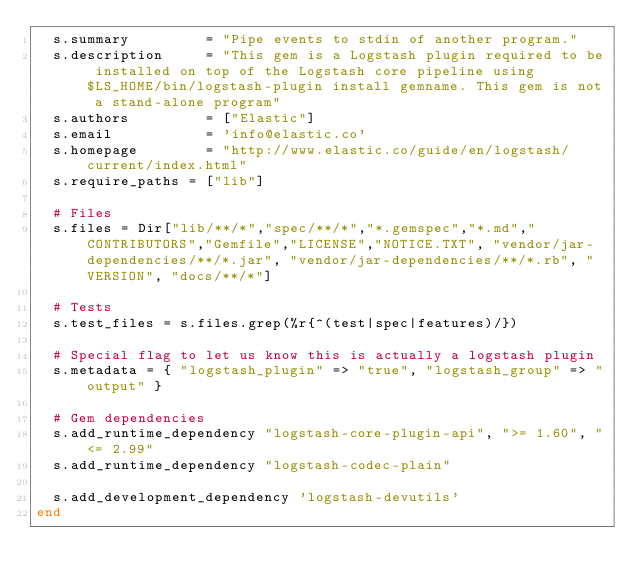<code> <loc_0><loc_0><loc_500><loc_500><_Ruby_>  s.summary         = "Pipe events to stdin of another program."
  s.description     = "This gem is a Logstash plugin required to be installed on top of the Logstash core pipeline using $LS_HOME/bin/logstash-plugin install gemname. This gem is not a stand-alone program"
  s.authors         = ["Elastic"]
  s.email           = 'info@elastic.co'
  s.homepage        = "http://www.elastic.co/guide/en/logstash/current/index.html"
  s.require_paths = ["lib"]

  # Files
  s.files = Dir["lib/**/*","spec/**/*","*.gemspec","*.md","CONTRIBUTORS","Gemfile","LICENSE","NOTICE.TXT", "vendor/jar-dependencies/**/*.jar", "vendor/jar-dependencies/**/*.rb", "VERSION", "docs/**/*"]

  # Tests
  s.test_files = s.files.grep(%r{^(test|spec|features)/})

  # Special flag to let us know this is actually a logstash plugin
  s.metadata = { "logstash_plugin" => "true", "logstash_group" => "output" }

  # Gem dependencies
  s.add_runtime_dependency "logstash-core-plugin-api", ">= 1.60", "<= 2.99"
  s.add_runtime_dependency "logstash-codec-plain"

  s.add_development_dependency 'logstash-devutils'
end

</code> 